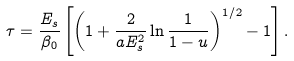<formula> <loc_0><loc_0><loc_500><loc_500>\tau = \frac { E _ { s } } { \beta _ { 0 } } \left [ \left ( 1 + \frac { 2 } { a E _ { s } ^ { 2 } } \ln \frac { 1 } { 1 - u } \right ) ^ { 1 / 2 } - 1 \right ] .</formula> 